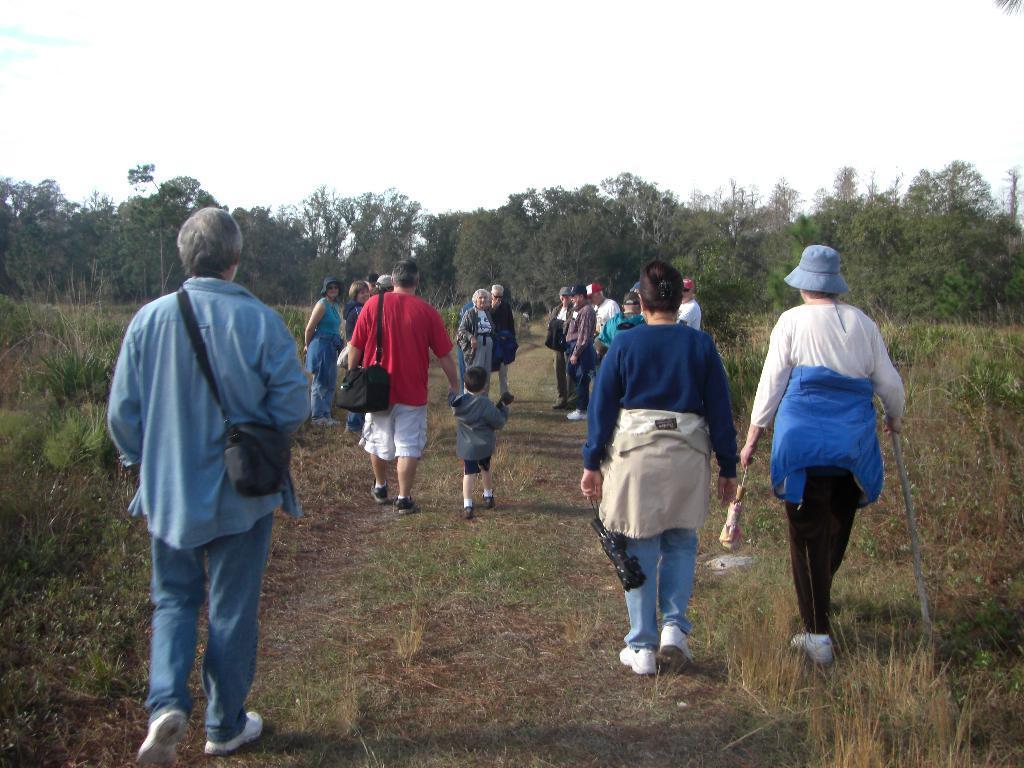Describe this image in one or two sentences. In this image we can see some people standing, carrying bags and holding objects. And we can see the dried grass and trees. At the top we can see the sky. 